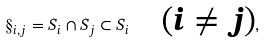Convert formula to latex. <formula><loc_0><loc_0><loc_500><loc_500>\S _ { i , j } = S _ { i } \cap S _ { j } \subset S _ { i } \quad \text {($i \neq j$)} ,</formula> 